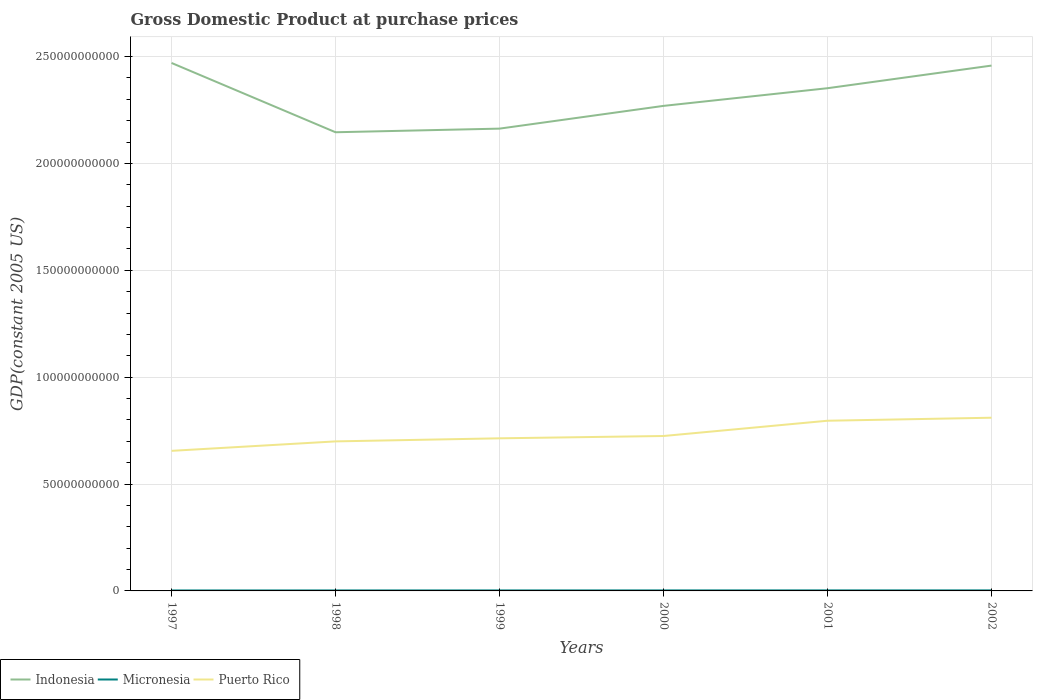Across all years, what is the maximum GDP at purchase prices in Indonesia?
Give a very brief answer. 2.15e+11. What is the total GDP at purchase prices in Puerto Rico in the graph?
Provide a succinct answer. -2.53e+09. What is the difference between the highest and the second highest GDP at purchase prices in Indonesia?
Offer a terse response. 3.24e+1. Is the GDP at purchase prices in Indonesia strictly greater than the GDP at purchase prices in Micronesia over the years?
Provide a short and direct response. No. Does the graph contain any zero values?
Your answer should be compact. No. Does the graph contain grids?
Offer a very short reply. Yes. How many legend labels are there?
Your answer should be very brief. 3. How are the legend labels stacked?
Make the answer very short. Horizontal. What is the title of the graph?
Your answer should be very brief. Gross Domestic Product at purchase prices. Does "Japan" appear as one of the legend labels in the graph?
Your response must be concise. No. What is the label or title of the Y-axis?
Offer a very short reply. GDP(constant 2005 US). What is the GDP(constant 2005 US) of Indonesia in 1997?
Offer a very short reply. 2.47e+11. What is the GDP(constant 2005 US) in Micronesia in 1997?
Keep it short and to the point. 2.22e+08. What is the GDP(constant 2005 US) of Puerto Rico in 1997?
Your response must be concise. 6.55e+1. What is the GDP(constant 2005 US) in Indonesia in 1998?
Provide a short and direct response. 2.15e+11. What is the GDP(constant 2005 US) of Micronesia in 1998?
Give a very brief answer. 2.29e+08. What is the GDP(constant 2005 US) of Puerto Rico in 1998?
Your answer should be very brief. 7.00e+1. What is the GDP(constant 2005 US) of Indonesia in 1999?
Give a very brief answer. 2.16e+11. What is the GDP(constant 2005 US) of Micronesia in 1999?
Keep it short and to the point. 2.32e+08. What is the GDP(constant 2005 US) in Puerto Rico in 1999?
Offer a very short reply. 7.14e+1. What is the GDP(constant 2005 US) of Indonesia in 2000?
Ensure brevity in your answer.  2.27e+11. What is the GDP(constant 2005 US) in Micronesia in 2000?
Your answer should be compact. 2.42e+08. What is the GDP(constant 2005 US) of Puerto Rico in 2000?
Offer a terse response. 7.25e+1. What is the GDP(constant 2005 US) of Indonesia in 2001?
Give a very brief answer. 2.35e+11. What is the GDP(constant 2005 US) of Micronesia in 2001?
Offer a very short reply. 2.47e+08. What is the GDP(constant 2005 US) of Puerto Rico in 2001?
Your answer should be compact. 7.96e+1. What is the GDP(constant 2005 US) in Indonesia in 2002?
Make the answer very short. 2.46e+11. What is the GDP(constant 2005 US) in Micronesia in 2002?
Make the answer very short. 2.48e+08. What is the GDP(constant 2005 US) in Puerto Rico in 2002?
Ensure brevity in your answer.  8.10e+1. Across all years, what is the maximum GDP(constant 2005 US) in Indonesia?
Your answer should be compact. 2.47e+11. Across all years, what is the maximum GDP(constant 2005 US) in Micronesia?
Make the answer very short. 2.48e+08. Across all years, what is the maximum GDP(constant 2005 US) of Puerto Rico?
Give a very brief answer. 8.10e+1. Across all years, what is the minimum GDP(constant 2005 US) of Indonesia?
Ensure brevity in your answer.  2.15e+11. Across all years, what is the minimum GDP(constant 2005 US) in Micronesia?
Offer a very short reply. 2.22e+08. Across all years, what is the minimum GDP(constant 2005 US) in Puerto Rico?
Offer a very short reply. 6.55e+1. What is the total GDP(constant 2005 US) in Indonesia in the graph?
Ensure brevity in your answer.  1.39e+12. What is the total GDP(constant 2005 US) of Micronesia in the graph?
Give a very brief answer. 1.42e+09. What is the total GDP(constant 2005 US) of Puerto Rico in the graph?
Ensure brevity in your answer.  4.40e+11. What is the difference between the GDP(constant 2005 US) of Indonesia in 1997 and that in 1998?
Make the answer very short. 3.24e+1. What is the difference between the GDP(constant 2005 US) in Micronesia in 1997 and that in 1998?
Your answer should be compact. -6.57e+06. What is the difference between the GDP(constant 2005 US) of Puerto Rico in 1997 and that in 1998?
Provide a short and direct response. -4.42e+09. What is the difference between the GDP(constant 2005 US) in Indonesia in 1997 and that in 1999?
Make the answer very short. 3.07e+1. What is the difference between the GDP(constant 2005 US) in Micronesia in 1997 and that in 1999?
Give a very brief answer. -9.73e+06. What is the difference between the GDP(constant 2005 US) in Puerto Rico in 1997 and that in 1999?
Provide a short and direct response. -5.87e+09. What is the difference between the GDP(constant 2005 US) in Indonesia in 1997 and that in 2000?
Ensure brevity in your answer.  2.01e+1. What is the difference between the GDP(constant 2005 US) in Micronesia in 1997 and that in 2000?
Offer a very short reply. -2.03e+07. What is the difference between the GDP(constant 2005 US) of Puerto Rico in 1997 and that in 2000?
Give a very brief answer. -6.95e+09. What is the difference between the GDP(constant 2005 US) of Indonesia in 1997 and that in 2001?
Offer a terse response. 1.18e+1. What is the difference between the GDP(constant 2005 US) in Micronesia in 1997 and that in 2001?
Offer a terse response. -2.46e+07. What is the difference between the GDP(constant 2005 US) of Puerto Rico in 1997 and that in 2001?
Give a very brief answer. -1.41e+1. What is the difference between the GDP(constant 2005 US) of Indonesia in 1997 and that in 2002?
Give a very brief answer. 1.24e+09. What is the difference between the GDP(constant 2005 US) of Micronesia in 1997 and that in 2002?
Give a very brief answer. -2.60e+07. What is the difference between the GDP(constant 2005 US) of Puerto Rico in 1997 and that in 2002?
Provide a succinct answer. -1.55e+1. What is the difference between the GDP(constant 2005 US) in Indonesia in 1998 and that in 1999?
Give a very brief answer. -1.70e+09. What is the difference between the GDP(constant 2005 US) of Micronesia in 1998 and that in 1999?
Your answer should be very brief. -3.17e+06. What is the difference between the GDP(constant 2005 US) in Puerto Rico in 1998 and that in 1999?
Give a very brief answer. -1.45e+09. What is the difference between the GDP(constant 2005 US) in Indonesia in 1998 and that in 2000?
Your response must be concise. -1.23e+1. What is the difference between the GDP(constant 2005 US) in Micronesia in 1998 and that in 2000?
Provide a short and direct response. -1.37e+07. What is the difference between the GDP(constant 2005 US) of Puerto Rico in 1998 and that in 2000?
Give a very brief answer. -2.53e+09. What is the difference between the GDP(constant 2005 US) of Indonesia in 1998 and that in 2001?
Ensure brevity in your answer.  -2.06e+1. What is the difference between the GDP(constant 2005 US) of Micronesia in 1998 and that in 2001?
Provide a succinct answer. -1.80e+07. What is the difference between the GDP(constant 2005 US) of Puerto Rico in 1998 and that in 2001?
Provide a short and direct response. -9.66e+09. What is the difference between the GDP(constant 2005 US) in Indonesia in 1998 and that in 2002?
Provide a short and direct response. -3.12e+1. What is the difference between the GDP(constant 2005 US) of Micronesia in 1998 and that in 2002?
Your answer should be very brief. -1.95e+07. What is the difference between the GDP(constant 2005 US) of Puerto Rico in 1998 and that in 2002?
Offer a terse response. -1.11e+1. What is the difference between the GDP(constant 2005 US) of Indonesia in 1999 and that in 2000?
Give a very brief answer. -1.06e+1. What is the difference between the GDP(constant 2005 US) in Micronesia in 1999 and that in 2000?
Your response must be concise. -1.06e+07. What is the difference between the GDP(constant 2005 US) in Puerto Rico in 1999 and that in 2000?
Offer a very short reply. -1.08e+09. What is the difference between the GDP(constant 2005 US) in Indonesia in 1999 and that in 2001?
Give a very brief answer. -1.89e+1. What is the difference between the GDP(constant 2005 US) of Micronesia in 1999 and that in 2001?
Offer a very short reply. -1.48e+07. What is the difference between the GDP(constant 2005 US) of Puerto Rico in 1999 and that in 2001?
Keep it short and to the point. -8.22e+09. What is the difference between the GDP(constant 2005 US) in Indonesia in 1999 and that in 2002?
Your answer should be compact. -2.95e+1. What is the difference between the GDP(constant 2005 US) of Micronesia in 1999 and that in 2002?
Your answer should be very brief. -1.63e+07. What is the difference between the GDP(constant 2005 US) in Puerto Rico in 1999 and that in 2002?
Give a very brief answer. -9.63e+09. What is the difference between the GDP(constant 2005 US) of Indonesia in 2000 and that in 2001?
Provide a short and direct response. -8.27e+09. What is the difference between the GDP(constant 2005 US) of Micronesia in 2000 and that in 2001?
Keep it short and to the point. -4.24e+06. What is the difference between the GDP(constant 2005 US) in Puerto Rico in 2000 and that in 2001?
Keep it short and to the point. -7.14e+09. What is the difference between the GDP(constant 2005 US) of Indonesia in 2000 and that in 2002?
Provide a succinct answer. -1.88e+1. What is the difference between the GDP(constant 2005 US) of Micronesia in 2000 and that in 2002?
Ensure brevity in your answer.  -5.72e+06. What is the difference between the GDP(constant 2005 US) of Puerto Rico in 2000 and that in 2002?
Keep it short and to the point. -8.55e+09. What is the difference between the GDP(constant 2005 US) in Indonesia in 2001 and that in 2002?
Your answer should be very brief. -1.06e+1. What is the difference between the GDP(constant 2005 US) of Micronesia in 2001 and that in 2002?
Provide a short and direct response. -1.48e+06. What is the difference between the GDP(constant 2005 US) in Puerto Rico in 2001 and that in 2002?
Make the answer very short. -1.41e+09. What is the difference between the GDP(constant 2005 US) of Indonesia in 1997 and the GDP(constant 2005 US) of Micronesia in 1998?
Keep it short and to the point. 2.47e+11. What is the difference between the GDP(constant 2005 US) of Indonesia in 1997 and the GDP(constant 2005 US) of Puerto Rico in 1998?
Ensure brevity in your answer.  1.77e+11. What is the difference between the GDP(constant 2005 US) in Micronesia in 1997 and the GDP(constant 2005 US) in Puerto Rico in 1998?
Provide a succinct answer. -6.97e+1. What is the difference between the GDP(constant 2005 US) of Indonesia in 1997 and the GDP(constant 2005 US) of Micronesia in 1999?
Your answer should be very brief. 2.47e+11. What is the difference between the GDP(constant 2005 US) in Indonesia in 1997 and the GDP(constant 2005 US) in Puerto Rico in 1999?
Make the answer very short. 1.76e+11. What is the difference between the GDP(constant 2005 US) of Micronesia in 1997 and the GDP(constant 2005 US) of Puerto Rico in 1999?
Your answer should be very brief. -7.12e+1. What is the difference between the GDP(constant 2005 US) of Indonesia in 1997 and the GDP(constant 2005 US) of Micronesia in 2000?
Offer a terse response. 2.47e+11. What is the difference between the GDP(constant 2005 US) in Indonesia in 1997 and the GDP(constant 2005 US) in Puerto Rico in 2000?
Give a very brief answer. 1.75e+11. What is the difference between the GDP(constant 2005 US) of Micronesia in 1997 and the GDP(constant 2005 US) of Puerto Rico in 2000?
Your response must be concise. -7.23e+1. What is the difference between the GDP(constant 2005 US) in Indonesia in 1997 and the GDP(constant 2005 US) in Micronesia in 2001?
Offer a very short reply. 2.47e+11. What is the difference between the GDP(constant 2005 US) of Indonesia in 1997 and the GDP(constant 2005 US) of Puerto Rico in 2001?
Your response must be concise. 1.67e+11. What is the difference between the GDP(constant 2005 US) in Micronesia in 1997 and the GDP(constant 2005 US) in Puerto Rico in 2001?
Your answer should be very brief. -7.94e+1. What is the difference between the GDP(constant 2005 US) in Indonesia in 1997 and the GDP(constant 2005 US) in Micronesia in 2002?
Keep it short and to the point. 2.47e+11. What is the difference between the GDP(constant 2005 US) of Indonesia in 1997 and the GDP(constant 2005 US) of Puerto Rico in 2002?
Make the answer very short. 1.66e+11. What is the difference between the GDP(constant 2005 US) in Micronesia in 1997 and the GDP(constant 2005 US) in Puerto Rico in 2002?
Make the answer very short. -8.08e+1. What is the difference between the GDP(constant 2005 US) of Indonesia in 1998 and the GDP(constant 2005 US) of Micronesia in 1999?
Provide a succinct answer. 2.14e+11. What is the difference between the GDP(constant 2005 US) in Indonesia in 1998 and the GDP(constant 2005 US) in Puerto Rico in 1999?
Make the answer very short. 1.43e+11. What is the difference between the GDP(constant 2005 US) in Micronesia in 1998 and the GDP(constant 2005 US) in Puerto Rico in 1999?
Your answer should be very brief. -7.12e+1. What is the difference between the GDP(constant 2005 US) in Indonesia in 1998 and the GDP(constant 2005 US) in Micronesia in 2000?
Your response must be concise. 2.14e+11. What is the difference between the GDP(constant 2005 US) of Indonesia in 1998 and the GDP(constant 2005 US) of Puerto Rico in 2000?
Provide a succinct answer. 1.42e+11. What is the difference between the GDP(constant 2005 US) in Micronesia in 1998 and the GDP(constant 2005 US) in Puerto Rico in 2000?
Keep it short and to the point. -7.23e+1. What is the difference between the GDP(constant 2005 US) of Indonesia in 1998 and the GDP(constant 2005 US) of Micronesia in 2001?
Offer a very short reply. 2.14e+11. What is the difference between the GDP(constant 2005 US) in Indonesia in 1998 and the GDP(constant 2005 US) in Puerto Rico in 2001?
Provide a short and direct response. 1.35e+11. What is the difference between the GDP(constant 2005 US) in Micronesia in 1998 and the GDP(constant 2005 US) in Puerto Rico in 2001?
Your response must be concise. -7.94e+1. What is the difference between the GDP(constant 2005 US) in Indonesia in 1998 and the GDP(constant 2005 US) in Micronesia in 2002?
Your response must be concise. 2.14e+11. What is the difference between the GDP(constant 2005 US) of Indonesia in 1998 and the GDP(constant 2005 US) of Puerto Rico in 2002?
Your response must be concise. 1.34e+11. What is the difference between the GDP(constant 2005 US) in Micronesia in 1998 and the GDP(constant 2005 US) in Puerto Rico in 2002?
Offer a terse response. -8.08e+1. What is the difference between the GDP(constant 2005 US) of Indonesia in 1999 and the GDP(constant 2005 US) of Micronesia in 2000?
Keep it short and to the point. 2.16e+11. What is the difference between the GDP(constant 2005 US) in Indonesia in 1999 and the GDP(constant 2005 US) in Puerto Rico in 2000?
Your answer should be compact. 1.44e+11. What is the difference between the GDP(constant 2005 US) in Micronesia in 1999 and the GDP(constant 2005 US) in Puerto Rico in 2000?
Make the answer very short. -7.22e+1. What is the difference between the GDP(constant 2005 US) in Indonesia in 1999 and the GDP(constant 2005 US) in Micronesia in 2001?
Provide a succinct answer. 2.16e+11. What is the difference between the GDP(constant 2005 US) in Indonesia in 1999 and the GDP(constant 2005 US) in Puerto Rico in 2001?
Your response must be concise. 1.37e+11. What is the difference between the GDP(constant 2005 US) in Micronesia in 1999 and the GDP(constant 2005 US) in Puerto Rico in 2001?
Keep it short and to the point. -7.94e+1. What is the difference between the GDP(constant 2005 US) in Indonesia in 1999 and the GDP(constant 2005 US) in Micronesia in 2002?
Your response must be concise. 2.16e+11. What is the difference between the GDP(constant 2005 US) of Indonesia in 1999 and the GDP(constant 2005 US) of Puerto Rico in 2002?
Provide a succinct answer. 1.35e+11. What is the difference between the GDP(constant 2005 US) in Micronesia in 1999 and the GDP(constant 2005 US) in Puerto Rico in 2002?
Make the answer very short. -8.08e+1. What is the difference between the GDP(constant 2005 US) in Indonesia in 2000 and the GDP(constant 2005 US) in Micronesia in 2001?
Keep it short and to the point. 2.27e+11. What is the difference between the GDP(constant 2005 US) of Indonesia in 2000 and the GDP(constant 2005 US) of Puerto Rico in 2001?
Offer a terse response. 1.47e+11. What is the difference between the GDP(constant 2005 US) in Micronesia in 2000 and the GDP(constant 2005 US) in Puerto Rico in 2001?
Offer a terse response. -7.94e+1. What is the difference between the GDP(constant 2005 US) in Indonesia in 2000 and the GDP(constant 2005 US) in Micronesia in 2002?
Ensure brevity in your answer.  2.27e+11. What is the difference between the GDP(constant 2005 US) in Indonesia in 2000 and the GDP(constant 2005 US) in Puerto Rico in 2002?
Your answer should be compact. 1.46e+11. What is the difference between the GDP(constant 2005 US) of Micronesia in 2000 and the GDP(constant 2005 US) of Puerto Rico in 2002?
Make the answer very short. -8.08e+1. What is the difference between the GDP(constant 2005 US) in Indonesia in 2001 and the GDP(constant 2005 US) in Micronesia in 2002?
Offer a very short reply. 2.35e+11. What is the difference between the GDP(constant 2005 US) of Indonesia in 2001 and the GDP(constant 2005 US) of Puerto Rico in 2002?
Keep it short and to the point. 1.54e+11. What is the difference between the GDP(constant 2005 US) in Micronesia in 2001 and the GDP(constant 2005 US) in Puerto Rico in 2002?
Keep it short and to the point. -8.08e+1. What is the average GDP(constant 2005 US) of Indonesia per year?
Make the answer very short. 2.31e+11. What is the average GDP(constant 2005 US) in Micronesia per year?
Provide a succinct answer. 2.37e+08. What is the average GDP(constant 2005 US) of Puerto Rico per year?
Give a very brief answer. 7.33e+1. In the year 1997, what is the difference between the GDP(constant 2005 US) in Indonesia and GDP(constant 2005 US) in Micronesia?
Your answer should be very brief. 2.47e+11. In the year 1997, what is the difference between the GDP(constant 2005 US) in Indonesia and GDP(constant 2005 US) in Puerto Rico?
Your answer should be very brief. 1.81e+11. In the year 1997, what is the difference between the GDP(constant 2005 US) of Micronesia and GDP(constant 2005 US) of Puerto Rico?
Provide a short and direct response. -6.53e+1. In the year 1998, what is the difference between the GDP(constant 2005 US) of Indonesia and GDP(constant 2005 US) of Micronesia?
Provide a short and direct response. 2.14e+11. In the year 1998, what is the difference between the GDP(constant 2005 US) of Indonesia and GDP(constant 2005 US) of Puerto Rico?
Your answer should be compact. 1.45e+11. In the year 1998, what is the difference between the GDP(constant 2005 US) of Micronesia and GDP(constant 2005 US) of Puerto Rico?
Your answer should be very brief. -6.97e+1. In the year 1999, what is the difference between the GDP(constant 2005 US) in Indonesia and GDP(constant 2005 US) in Micronesia?
Make the answer very short. 2.16e+11. In the year 1999, what is the difference between the GDP(constant 2005 US) in Indonesia and GDP(constant 2005 US) in Puerto Rico?
Offer a very short reply. 1.45e+11. In the year 1999, what is the difference between the GDP(constant 2005 US) of Micronesia and GDP(constant 2005 US) of Puerto Rico?
Give a very brief answer. -7.12e+1. In the year 2000, what is the difference between the GDP(constant 2005 US) of Indonesia and GDP(constant 2005 US) of Micronesia?
Ensure brevity in your answer.  2.27e+11. In the year 2000, what is the difference between the GDP(constant 2005 US) in Indonesia and GDP(constant 2005 US) in Puerto Rico?
Your response must be concise. 1.54e+11. In the year 2000, what is the difference between the GDP(constant 2005 US) in Micronesia and GDP(constant 2005 US) in Puerto Rico?
Give a very brief answer. -7.22e+1. In the year 2001, what is the difference between the GDP(constant 2005 US) of Indonesia and GDP(constant 2005 US) of Micronesia?
Give a very brief answer. 2.35e+11. In the year 2001, what is the difference between the GDP(constant 2005 US) of Indonesia and GDP(constant 2005 US) of Puerto Rico?
Offer a terse response. 1.56e+11. In the year 2001, what is the difference between the GDP(constant 2005 US) of Micronesia and GDP(constant 2005 US) of Puerto Rico?
Offer a terse response. -7.94e+1. In the year 2002, what is the difference between the GDP(constant 2005 US) of Indonesia and GDP(constant 2005 US) of Micronesia?
Offer a terse response. 2.46e+11. In the year 2002, what is the difference between the GDP(constant 2005 US) of Indonesia and GDP(constant 2005 US) of Puerto Rico?
Ensure brevity in your answer.  1.65e+11. In the year 2002, what is the difference between the GDP(constant 2005 US) of Micronesia and GDP(constant 2005 US) of Puerto Rico?
Offer a very short reply. -8.08e+1. What is the ratio of the GDP(constant 2005 US) of Indonesia in 1997 to that in 1998?
Your response must be concise. 1.15. What is the ratio of the GDP(constant 2005 US) of Micronesia in 1997 to that in 1998?
Provide a short and direct response. 0.97. What is the ratio of the GDP(constant 2005 US) of Puerto Rico in 1997 to that in 1998?
Offer a terse response. 0.94. What is the ratio of the GDP(constant 2005 US) of Indonesia in 1997 to that in 1999?
Offer a terse response. 1.14. What is the ratio of the GDP(constant 2005 US) in Micronesia in 1997 to that in 1999?
Provide a succinct answer. 0.96. What is the ratio of the GDP(constant 2005 US) of Puerto Rico in 1997 to that in 1999?
Give a very brief answer. 0.92. What is the ratio of the GDP(constant 2005 US) of Indonesia in 1997 to that in 2000?
Offer a terse response. 1.09. What is the ratio of the GDP(constant 2005 US) in Micronesia in 1997 to that in 2000?
Provide a succinct answer. 0.92. What is the ratio of the GDP(constant 2005 US) in Puerto Rico in 1997 to that in 2000?
Provide a short and direct response. 0.9. What is the ratio of the GDP(constant 2005 US) in Indonesia in 1997 to that in 2001?
Your answer should be very brief. 1.05. What is the ratio of the GDP(constant 2005 US) in Micronesia in 1997 to that in 2001?
Make the answer very short. 0.9. What is the ratio of the GDP(constant 2005 US) in Puerto Rico in 1997 to that in 2001?
Offer a very short reply. 0.82. What is the ratio of the GDP(constant 2005 US) of Indonesia in 1997 to that in 2002?
Provide a short and direct response. 1. What is the ratio of the GDP(constant 2005 US) of Micronesia in 1997 to that in 2002?
Your answer should be very brief. 0.9. What is the ratio of the GDP(constant 2005 US) of Puerto Rico in 1997 to that in 2002?
Ensure brevity in your answer.  0.81. What is the ratio of the GDP(constant 2005 US) in Indonesia in 1998 to that in 1999?
Give a very brief answer. 0.99. What is the ratio of the GDP(constant 2005 US) in Micronesia in 1998 to that in 1999?
Ensure brevity in your answer.  0.99. What is the ratio of the GDP(constant 2005 US) of Puerto Rico in 1998 to that in 1999?
Your answer should be very brief. 0.98. What is the ratio of the GDP(constant 2005 US) of Indonesia in 1998 to that in 2000?
Offer a terse response. 0.95. What is the ratio of the GDP(constant 2005 US) of Micronesia in 1998 to that in 2000?
Make the answer very short. 0.94. What is the ratio of the GDP(constant 2005 US) in Puerto Rico in 1998 to that in 2000?
Provide a succinct answer. 0.97. What is the ratio of the GDP(constant 2005 US) in Indonesia in 1998 to that in 2001?
Make the answer very short. 0.91. What is the ratio of the GDP(constant 2005 US) of Micronesia in 1998 to that in 2001?
Your answer should be compact. 0.93. What is the ratio of the GDP(constant 2005 US) of Puerto Rico in 1998 to that in 2001?
Provide a succinct answer. 0.88. What is the ratio of the GDP(constant 2005 US) in Indonesia in 1998 to that in 2002?
Offer a terse response. 0.87. What is the ratio of the GDP(constant 2005 US) in Micronesia in 1998 to that in 2002?
Offer a terse response. 0.92. What is the ratio of the GDP(constant 2005 US) in Puerto Rico in 1998 to that in 2002?
Give a very brief answer. 0.86. What is the ratio of the GDP(constant 2005 US) of Indonesia in 1999 to that in 2000?
Ensure brevity in your answer.  0.95. What is the ratio of the GDP(constant 2005 US) in Micronesia in 1999 to that in 2000?
Make the answer very short. 0.96. What is the ratio of the GDP(constant 2005 US) of Puerto Rico in 1999 to that in 2000?
Your answer should be very brief. 0.99. What is the ratio of the GDP(constant 2005 US) of Indonesia in 1999 to that in 2001?
Give a very brief answer. 0.92. What is the ratio of the GDP(constant 2005 US) of Micronesia in 1999 to that in 2001?
Provide a succinct answer. 0.94. What is the ratio of the GDP(constant 2005 US) of Puerto Rico in 1999 to that in 2001?
Give a very brief answer. 0.9. What is the ratio of the GDP(constant 2005 US) of Indonesia in 1999 to that in 2002?
Provide a short and direct response. 0.88. What is the ratio of the GDP(constant 2005 US) of Micronesia in 1999 to that in 2002?
Give a very brief answer. 0.93. What is the ratio of the GDP(constant 2005 US) in Puerto Rico in 1999 to that in 2002?
Keep it short and to the point. 0.88. What is the ratio of the GDP(constant 2005 US) of Indonesia in 2000 to that in 2001?
Your answer should be very brief. 0.96. What is the ratio of the GDP(constant 2005 US) of Micronesia in 2000 to that in 2001?
Offer a very short reply. 0.98. What is the ratio of the GDP(constant 2005 US) of Puerto Rico in 2000 to that in 2001?
Offer a very short reply. 0.91. What is the ratio of the GDP(constant 2005 US) in Indonesia in 2000 to that in 2002?
Your answer should be very brief. 0.92. What is the ratio of the GDP(constant 2005 US) in Puerto Rico in 2000 to that in 2002?
Provide a short and direct response. 0.89. What is the ratio of the GDP(constant 2005 US) in Indonesia in 2001 to that in 2002?
Ensure brevity in your answer.  0.96. What is the ratio of the GDP(constant 2005 US) in Micronesia in 2001 to that in 2002?
Offer a very short reply. 0.99. What is the ratio of the GDP(constant 2005 US) in Puerto Rico in 2001 to that in 2002?
Make the answer very short. 0.98. What is the difference between the highest and the second highest GDP(constant 2005 US) in Indonesia?
Give a very brief answer. 1.24e+09. What is the difference between the highest and the second highest GDP(constant 2005 US) in Micronesia?
Your answer should be compact. 1.48e+06. What is the difference between the highest and the second highest GDP(constant 2005 US) in Puerto Rico?
Ensure brevity in your answer.  1.41e+09. What is the difference between the highest and the lowest GDP(constant 2005 US) in Indonesia?
Give a very brief answer. 3.24e+1. What is the difference between the highest and the lowest GDP(constant 2005 US) in Micronesia?
Your answer should be very brief. 2.60e+07. What is the difference between the highest and the lowest GDP(constant 2005 US) in Puerto Rico?
Provide a short and direct response. 1.55e+1. 